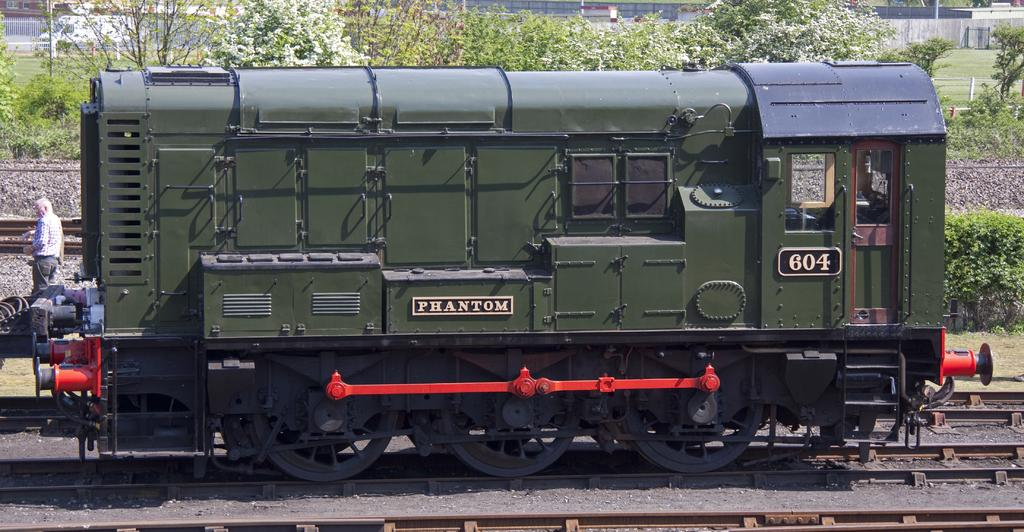What is the main subject of the image? The main subject of the image is a train on the track. Can you describe any other elements in the image? Yes, there is an old man walking on the left side of the image, and there are trees in the background. What type of sheet is covering the snail in the image? There is no snail or sheet present in the image. Can you describe the insect that is crawling on the train in the image? There is no insect visible on the train in the image. 